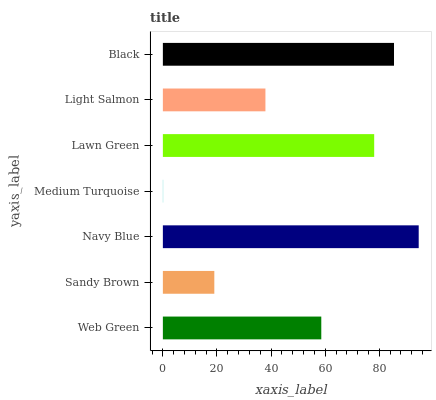Is Medium Turquoise the minimum?
Answer yes or no. Yes. Is Navy Blue the maximum?
Answer yes or no. Yes. Is Sandy Brown the minimum?
Answer yes or no. No. Is Sandy Brown the maximum?
Answer yes or no. No. Is Web Green greater than Sandy Brown?
Answer yes or no. Yes. Is Sandy Brown less than Web Green?
Answer yes or no. Yes. Is Sandy Brown greater than Web Green?
Answer yes or no. No. Is Web Green less than Sandy Brown?
Answer yes or no. No. Is Web Green the high median?
Answer yes or no. Yes. Is Web Green the low median?
Answer yes or no. Yes. Is Lawn Green the high median?
Answer yes or no. No. Is Black the low median?
Answer yes or no. No. 